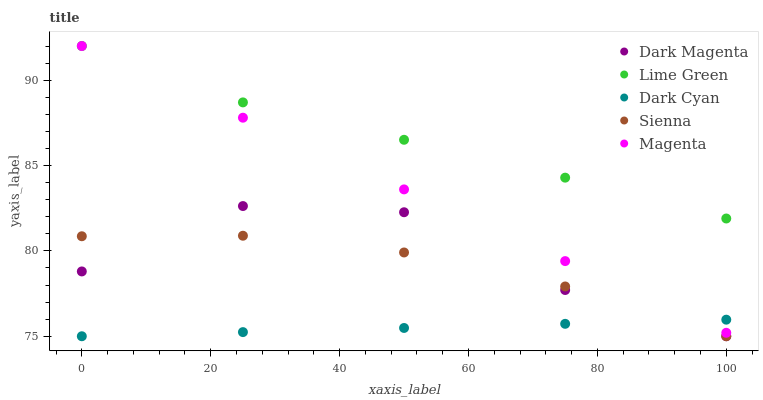Does Dark Cyan have the minimum area under the curve?
Answer yes or no. Yes. Does Lime Green have the maximum area under the curve?
Answer yes or no. Yes. Does Sienna have the minimum area under the curve?
Answer yes or no. No. Does Sienna have the maximum area under the curve?
Answer yes or no. No. Is Dark Cyan the smoothest?
Answer yes or no. Yes. Is Dark Magenta the roughest?
Answer yes or no. Yes. Is Sienna the smoothest?
Answer yes or no. No. Is Sienna the roughest?
Answer yes or no. No. Does Dark Cyan have the lowest value?
Answer yes or no. Yes. Does Magenta have the lowest value?
Answer yes or no. No. Does Lime Green have the highest value?
Answer yes or no. Yes. Does Sienna have the highest value?
Answer yes or no. No. Is Dark Cyan less than Lime Green?
Answer yes or no. Yes. Is Lime Green greater than Sienna?
Answer yes or no. Yes. Does Dark Magenta intersect Dark Cyan?
Answer yes or no. Yes. Is Dark Magenta less than Dark Cyan?
Answer yes or no. No. Is Dark Magenta greater than Dark Cyan?
Answer yes or no. No. Does Dark Cyan intersect Lime Green?
Answer yes or no. No. 